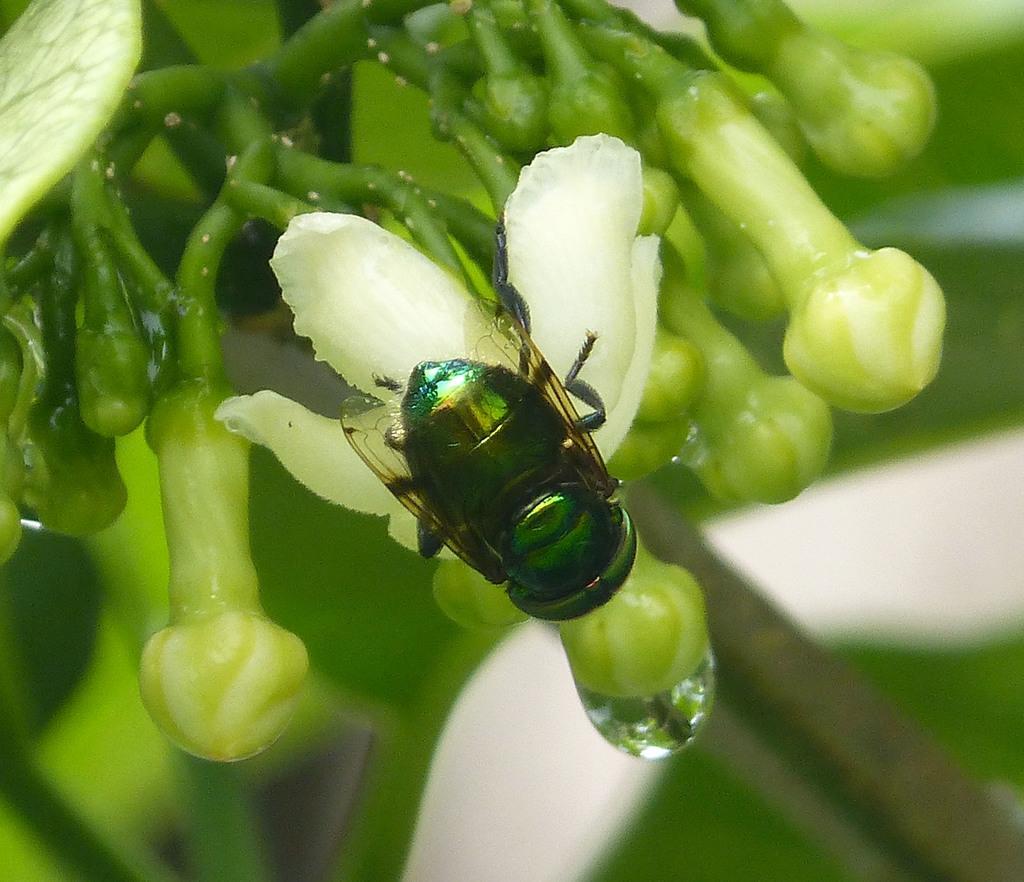Describe this image in one or two sentences. In this image, I can see a house fly on a flower. These are the flower buds to the stem. I can see a water drop. The background looks blurry. 